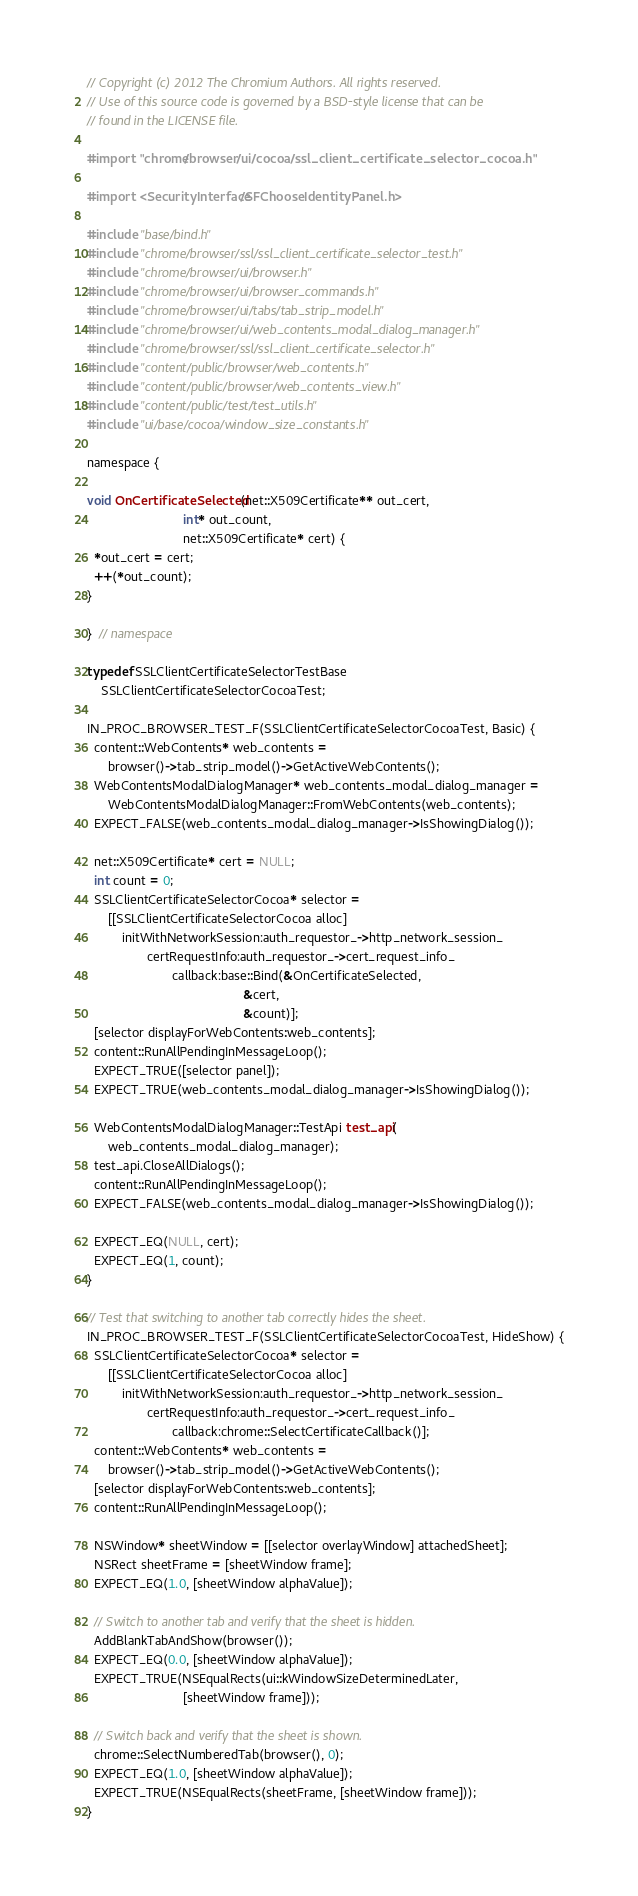Convert code to text. <code><loc_0><loc_0><loc_500><loc_500><_ObjectiveC_>// Copyright (c) 2012 The Chromium Authors. All rights reserved.
// Use of this source code is governed by a BSD-style license that can be
// found in the LICENSE file.

#import "chrome/browser/ui/cocoa/ssl_client_certificate_selector_cocoa.h"

#import <SecurityInterface/SFChooseIdentityPanel.h>

#include "base/bind.h"
#include "chrome/browser/ssl/ssl_client_certificate_selector_test.h"
#include "chrome/browser/ui/browser.h"
#include "chrome/browser/ui/browser_commands.h"
#include "chrome/browser/ui/tabs/tab_strip_model.h"
#include "chrome/browser/ui/web_contents_modal_dialog_manager.h"
#include "chrome/browser/ssl/ssl_client_certificate_selector.h"
#include "content/public/browser/web_contents.h"
#include "content/public/browser/web_contents_view.h"
#include "content/public/test/test_utils.h"
#include "ui/base/cocoa/window_size_constants.h"

namespace {

void OnCertificateSelected(net::X509Certificate** out_cert,
                           int* out_count,
                           net::X509Certificate* cert) {
  *out_cert = cert;
  ++(*out_count);
}

}  // namespace

typedef SSLClientCertificateSelectorTestBase
    SSLClientCertificateSelectorCocoaTest;

IN_PROC_BROWSER_TEST_F(SSLClientCertificateSelectorCocoaTest, Basic) {
  content::WebContents* web_contents =
      browser()->tab_strip_model()->GetActiveWebContents();
  WebContentsModalDialogManager* web_contents_modal_dialog_manager =
      WebContentsModalDialogManager::FromWebContents(web_contents);
  EXPECT_FALSE(web_contents_modal_dialog_manager->IsShowingDialog());

  net::X509Certificate* cert = NULL;
  int count = 0;
  SSLClientCertificateSelectorCocoa* selector =
      [[SSLClientCertificateSelectorCocoa alloc]
          initWithNetworkSession:auth_requestor_->http_network_session_
                 certRequestInfo:auth_requestor_->cert_request_info_
                        callback:base::Bind(&OnCertificateSelected,
                                            &cert,
                                            &count)];
  [selector displayForWebContents:web_contents];
  content::RunAllPendingInMessageLoop();
  EXPECT_TRUE([selector panel]);
  EXPECT_TRUE(web_contents_modal_dialog_manager->IsShowingDialog());

  WebContentsModalDialogManager::TestApi test_api(
      web_contents_modal_dialog_manager);
  test_api.CloseAllDialogs();
  content::RunAllPendingInMessageLoop();
  EXPECT_FALSE(web_contents_modal_dialog_manager->IsShowingDialog());

  EXPECT_EQ(NULL, cert);
  EXPECT_EQ(1, count);
}

// Test that switching to another tab correctly hides the sheet.
IN_PROC_BROWSER_TEST_F(SSLClientCertificateSelectorCocoaTest, HideShow) {
  SSLClientCertificateSelectorCocoa* selector =
      [[SSLClientCertificateSelectorCocoa alloc]
          initWithNetworkSession:auth_requestor_->http_network_session_
                 certRequestInfo:auth_requestor_->cert_request_info_
                        callback:chrome::SelectCertificateCallback()];
  content::WebContents* web_contents =
      browser()->tab_strip_model()->GetActiveWebContents();
  [selector displayForWebContents:web_contents];
  content::RunAllPendingInMessageLoop();

  NSWindow* sheetWindow = [[selector overlayWindow] attachedSheet];
  NSRect sheetFrame = [sheetWindow frame];
  EXPECT_EQ(1.0, [sheetWindow alphaValue]);

  // Switch to another tab and verify that the sheet is hidden.
  AddBlankTabAndShow(browser());
  EXPECT_EQ(0.0, [sheetWindow alphaValue]);
  EXPECT_TRUE(NSEqualRects(ui::kWindowSizeDeterminedLater,
                           [sheetWindow frame]));

  // Switch back and verify that the sheet is shown.
  chrome::SelectNumberedTab(browser(), 0);
  EXPECT_EQ(1.0, [sheetWindow alphaValue]);
  EXPECT_TRUE(NSEqualRects(sheetFrame, [sheetWindow frame]));
}
</code> 